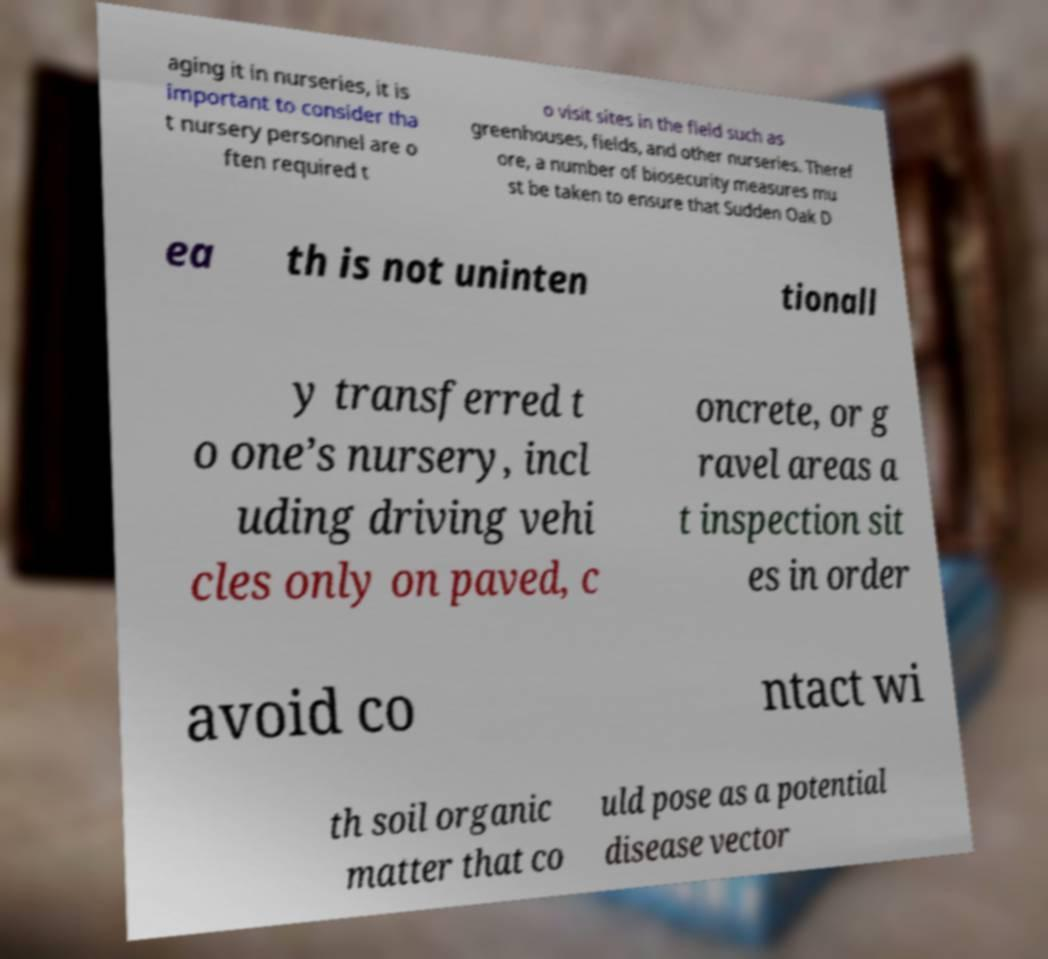For documentation purposes, I need the text within this image transcribed. Could you provide that? aging it in nurseries, it is important to consider tha t nursery personnel are o ften required t o visit sites in the field such as greenhouses, fields, and other nurseries. Theref ore, a number of biosecurity measures mu st be taken to ensure that Sudden Oak D ea th is not uninten tionall y transferred t o one’s nursery, incl uding driving vehi cles only on paved, c oncrete, or g ravel areas a t inspection sit es in order avoid co ntact wi th soil organic matter that co uld pose as a potential disease vector 